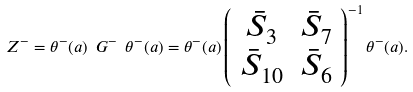<formula> <loc_0><loc_0><loc_500><loc_500>Z ^ { - } = \theta ^ { - } ( a ) \ G ^ { - } \ \theta ^ { - } ( a ) = \theta ^ { - } ( a ) \left ( \begin{array} { c c } \bar { S } _ { 3 } & \bar { S } _ { 7 } \\ \bar { S } _ { 1 0 } & \bar { S } _ { 6 } \end{array} \right ) ^ { - 1 } \theta ^ { - } ( a ) .</formula> 